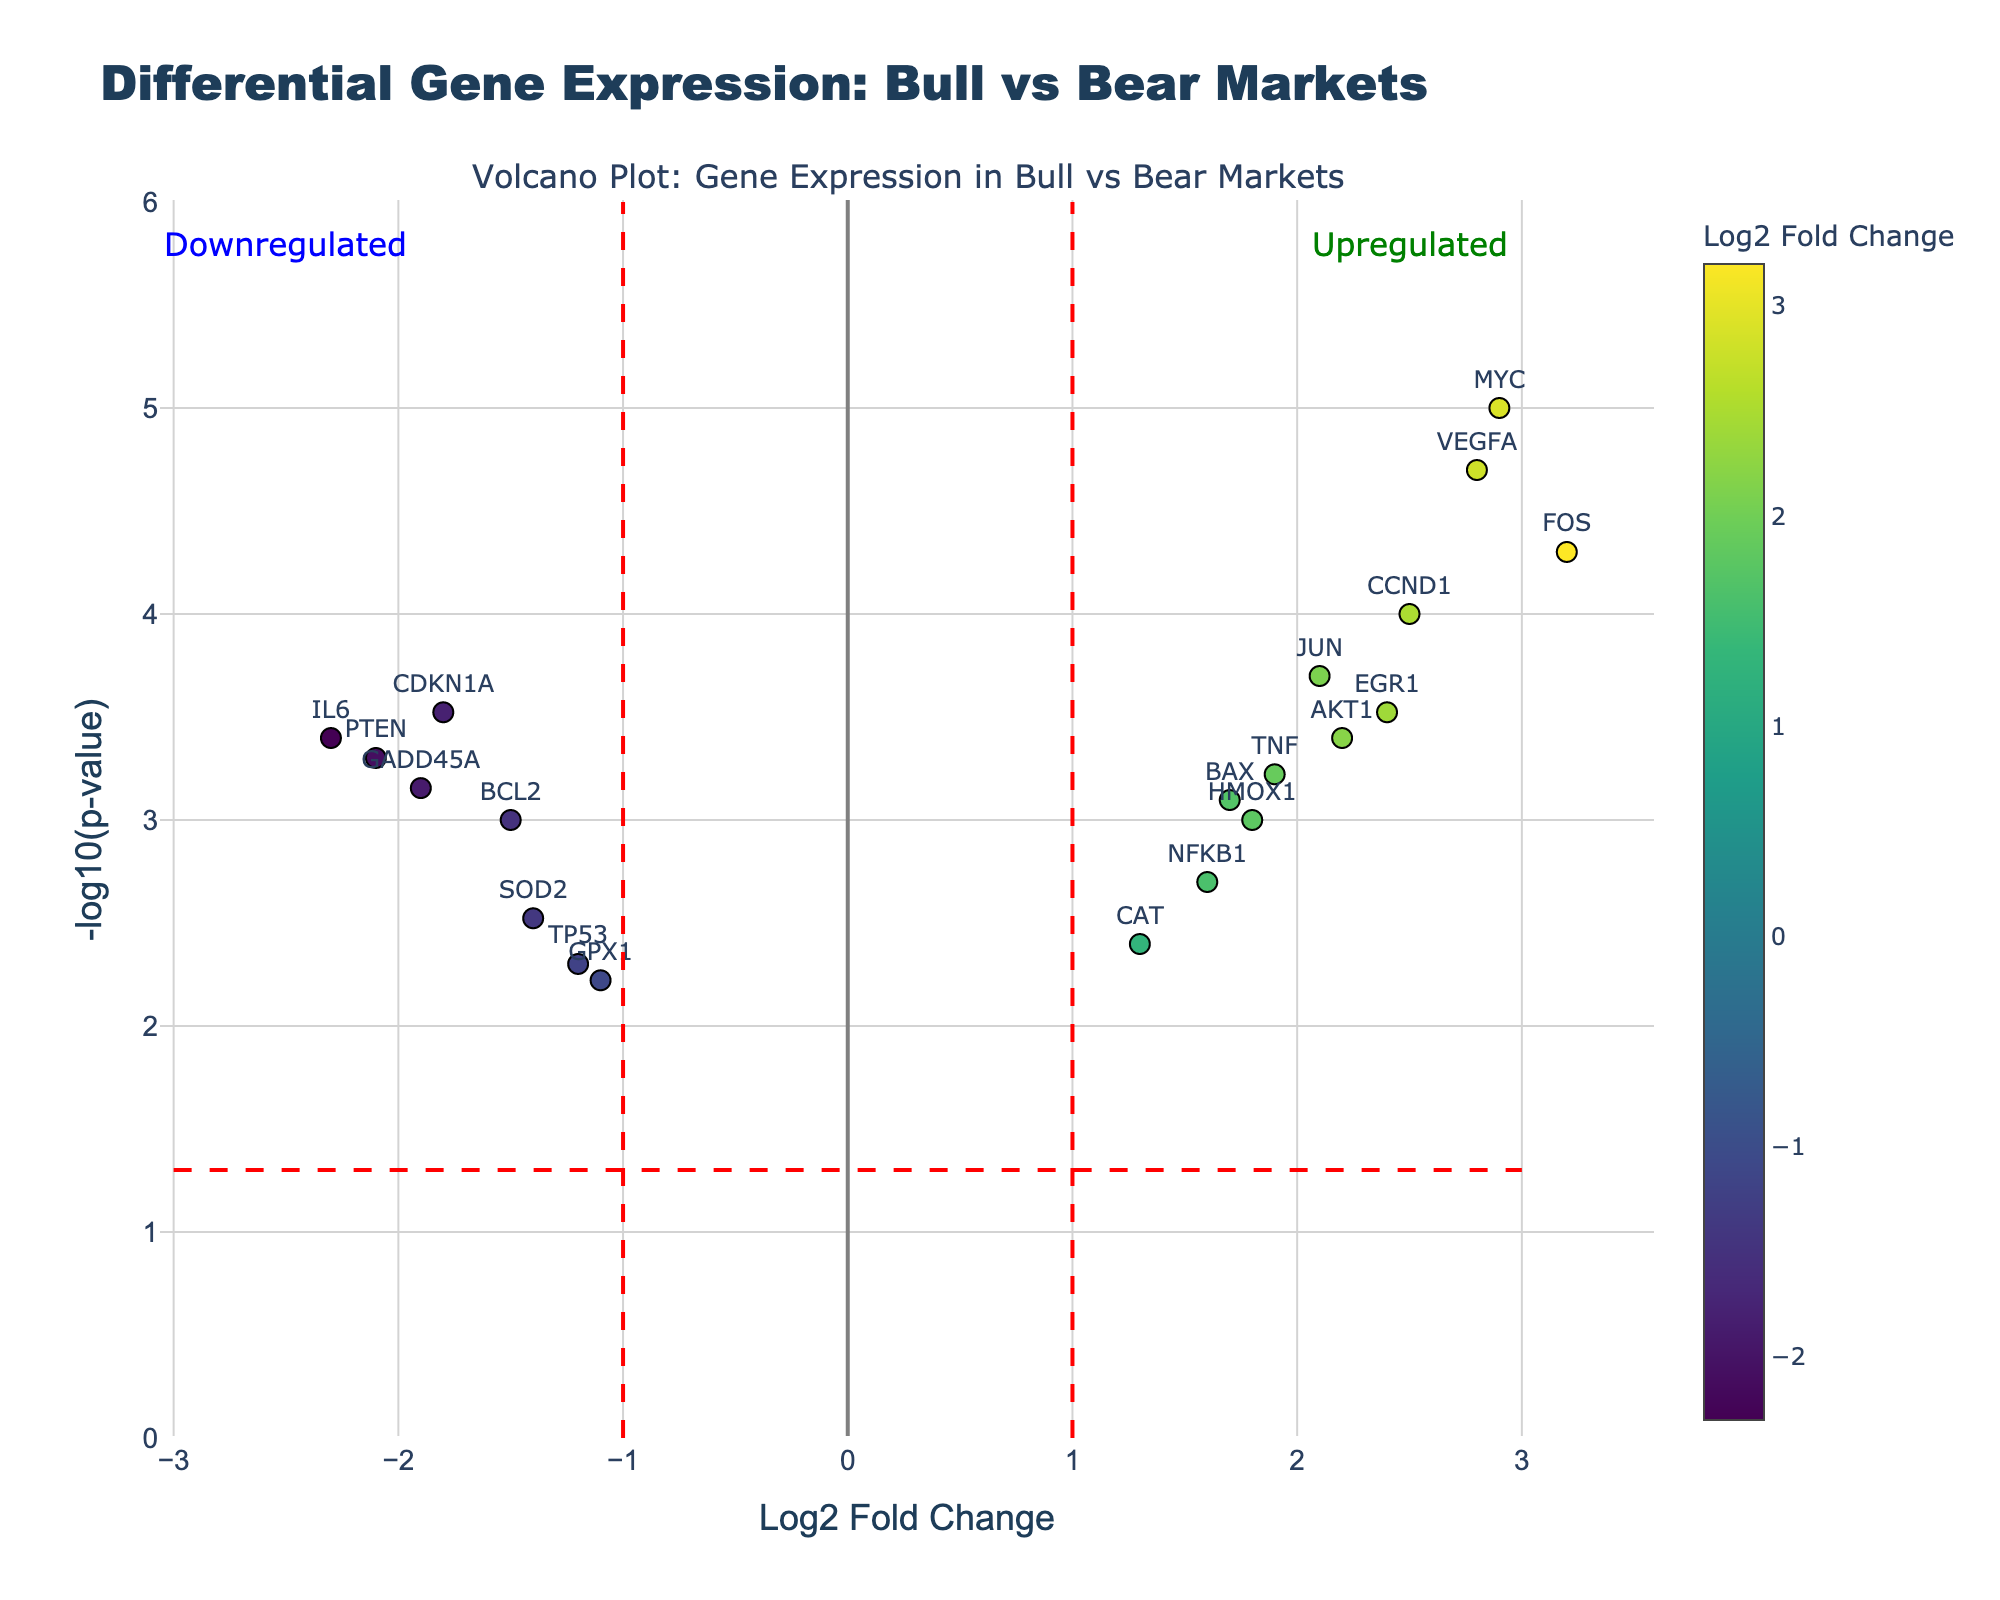What is the title of the plot? The title of the plot is usually located at the top center. In this case, it reads "Differential Gene Expression: Bull vs Bear Markets."
Answer: Differential Gene Expression: Bull vs Bear Markets What's the gene with the highest Log2 Fold Change? The highest Log2 Fold Change is the farthest point to the right on the x-axis. The gene associated with this point is "FOS" with a Log2 Fold Change of 3.2.
Answer: FOS Which gene has the smallest p-value? The smallest p-value corresponds to the highest point on the y-axis, as lower p-values translate into higher -log10(p-value). The gene is "MYC" with a -log10(p-value) of 5.0.
Answer: MYC How many genes are upregulated with a Log2 Fold Change greater than 2? Upregulated genes with a Log2 Fold Change greater than 2 are those having points at the right side with Log2 Fold Change > 2. These genes are "CCND1," "FOS," "VEGFA," "MYC," and "EGR1."
Answer: 5 How many genes have a p-value less than 0.05? Genes with a p-value less than 0.05 appear above the red horizontal dashed line, which indicates -log10(p-value) > 1.3. Count all such points. There are twelve such genes.
Answer: 12 Compare the expression of "TP53" and "MYC." Which is more significantly regulated? TP53 is at position (-1.2, -log10(0.005)), and MYC is at position (2.9, -log10(0.00001)). -log10(0.005) is smaller than -log10(0.00001), showing that MYC has a lower p-value and is more significantly regulated.
Answer: MYC What is the Log2 Fold Change for EGR1, and what does this indicate about its regulation in the market conditions? EGR1 has a Log2 Fold Change of 2.4, indicating it is upregulated in bull market conditions compared to bear market conditions.
Answer: 2.4, upregulated Which genes are downregulated with a Log2 Fold Change less than -2? Downregulated genes with Log2 Fold Change less than -2 are located to the left of the vertical red dashed line at -2. They are "IL6" and "PTEN."
Answer: IL6, PTEN Which gene is the closest to the intersection of the red dashed lines? The intersection of the red dashed lines is at (1, -log10(0.05)). The gene "NFKB1" is the closest to this point, at (1.6, -log10(0.002)).
Answer: NFKB1 